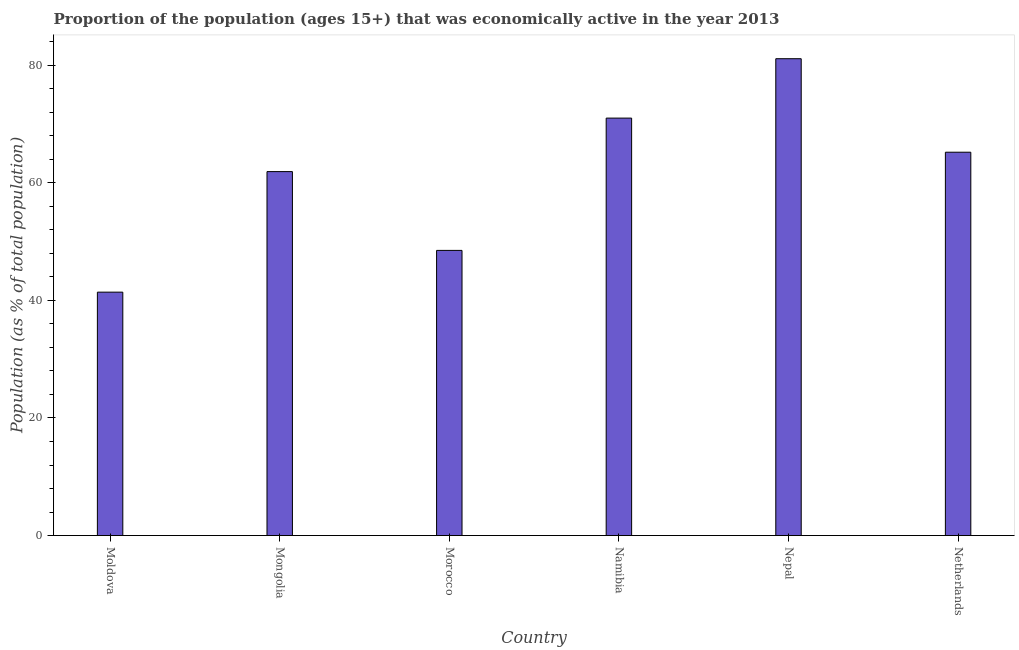What is the title of the graph?
Ensure brevity in your answer.  Proportion of the population (ages 15+) that was economically active in the year 2013. What is the label or title of the X-axis?
Offer a very short reply. Country. What is the label or title of the Y-axis?
Offer a very short reply. Population (as % of total population). What is the percentage of economically active population in Morocco?
Your answer should be compact. 48.5. Across all countries, what is the maximum percentage of economically active population?
Give a very brief answer. 81.1. Across all countries, what is the minimum percentage of economically active population?
Ensure brevity in your answer.  41.4. In which country was the percentage of economically active population maximum?
Offer a very short reply. Nepal. In which country was the percentage of economically active population minimum?
Ensure brevity in your answer.  Moldova. What is the sum of the percentage of economically active population?
Offer a very short reply. 369.1. What is the difference between the percentage of economically active population in Mongolia and Nepal?
Provide a short and direct response. -19.2. What is the average percentage of economically active population per country?
Keep it short and to the point. 61.52. What is the median percentage of economically active population?
Provide a succinct answer. 63.55. In how many countries, is the percentage of economically active population greater than 28 %?
Ensure brevity in your answer.  6. What is the ratio of the percentage of economically active population in Moldova to that in Nepal?
Offer a terse response. 0.51. Is the percentage of economically active population in Mongolia less than that in Nepal?
Ensure brevity in your answer.  Yes. What is the difference between the highest and the lowest percentage of economically active population?
Your answer should be very brief. 39.7. How many bars are there?
Provide a succinct answer. 6. Are all the bars in the graph horizontal?
Give a very brief answer. No. What is the difference between two consecutive major ticks on the Y-axis?
Your response must be concise. 20. What is the Population (as % of total population) in Moldova?
Your response must be concise. 41.4. What is the Population (as % of total population) of Mongolia?
Keep it short and to the point. 61.9. What is the Population (as % of total population) in Morocco?
Your answer should be compact. 48.5. What is the Population (as % of total population) in Nepal?
Your answer should be compact. 81.1. What is the Population (as % of total population) in Netherlands?
Provide a succinct answer. 65.2. What is the difference between the Population (as % of total population) in Moldova and Mongolia?
Your answer should be compact. -20.5. What is the difference between the Population (as % of total population) in Moldova and Morocco?
Your response must be concise. -7.1. What is the difference between the Population (as % of total population) in Moldova and Namibia?
Make the answer very short. -29.6. What is the difference between the Population (as % of total population) in Moldova and Nepal?
Offer a very short reply. -39.7. What is the difference between the Population (as % of total population) in Moldova and Netherlands?
Your answer should be very brief. -23.8. What is the difference between the Population (as % of total population) in Mongolia and Namibia?
Keep it short and to the point. -9.1. What is the difference between the Population (as % of total population) in Mongolia and Nepal?
Ensure brevity in your answer.  -19.2. What is the difference between the Population (as % of total population) in Morocco and Namibia?
Your answer should be very brief. -22.5. What is the difference between the Population (as % of total population) in Morocco and Nepal?
Make the answer very short. -32.6. What is the difference between the Population (as % of total population) in Morocco and Netherlands?
Make the answer very short. -16.7. What is the difference between the Population (as % of total population) in Namibia and Nepal?
Make the answer very short. -10.1. What is the ratio of the Population (as % of total population) in Moldova to that in Mongolia?
Provide a short and direct response. 0.67. What is the ratio of the Population (as % of total population) in Moldova to that in Morocco?
Give a very brief answer. 0.85. What is the ratio of the Population (as % of total population) in Moldova to that in Namibia?
Offer a terse response. 0.58. What is the ratio of the Population (as % of total population) in Moldova to that in Nepal?
Ensure brevity in your answer.  0.51. What is the ratio of the Population (as % of total population) in Moldova to that in Netherlands?
Give a very brief answer. 0.64. What is the ratio of the Population (as % of total population) in Mongolia to that in Morocco?
Give a very brief answer. 1.28. What is the ratio of the Population (as % of total population) in Mongolia to that in Namibia?
Offer a terse response. 0.87. What is the ratio of the Population (as % of total population) in Mongolia to that in Nepal?
Keep it short and to the point. 0.76. What is the ratio of the Population (as % of total population) in Mongolia to that in Netherlands?
Make the answer very short. 0.95. What is the ratio of the Population (as % of total population) in Morocco to that in Namibia?
Offer a very short reply. 0.68. What is the ratio of the Population (as % of total population) in Morocco to that in Nepal?
Your response must be concise. 0.6. What is the ratio of the Population (as % of total population) in Morocco to that in Netherlands?
Your response must be concise. 0.74. What is the ratio of the Population (as % of total population) in Namibia to that in Nepal?
Ensure brevity in your answer.  0.88. What is the ratio of the Population (as % of total population) in Namibia to that in Netherlands?
Your response must be concise. 1.09. What is the ratio of the Population (as % of total population) in Nepal to that in Netherlands?
Provide a succinct answer. 1.24. 